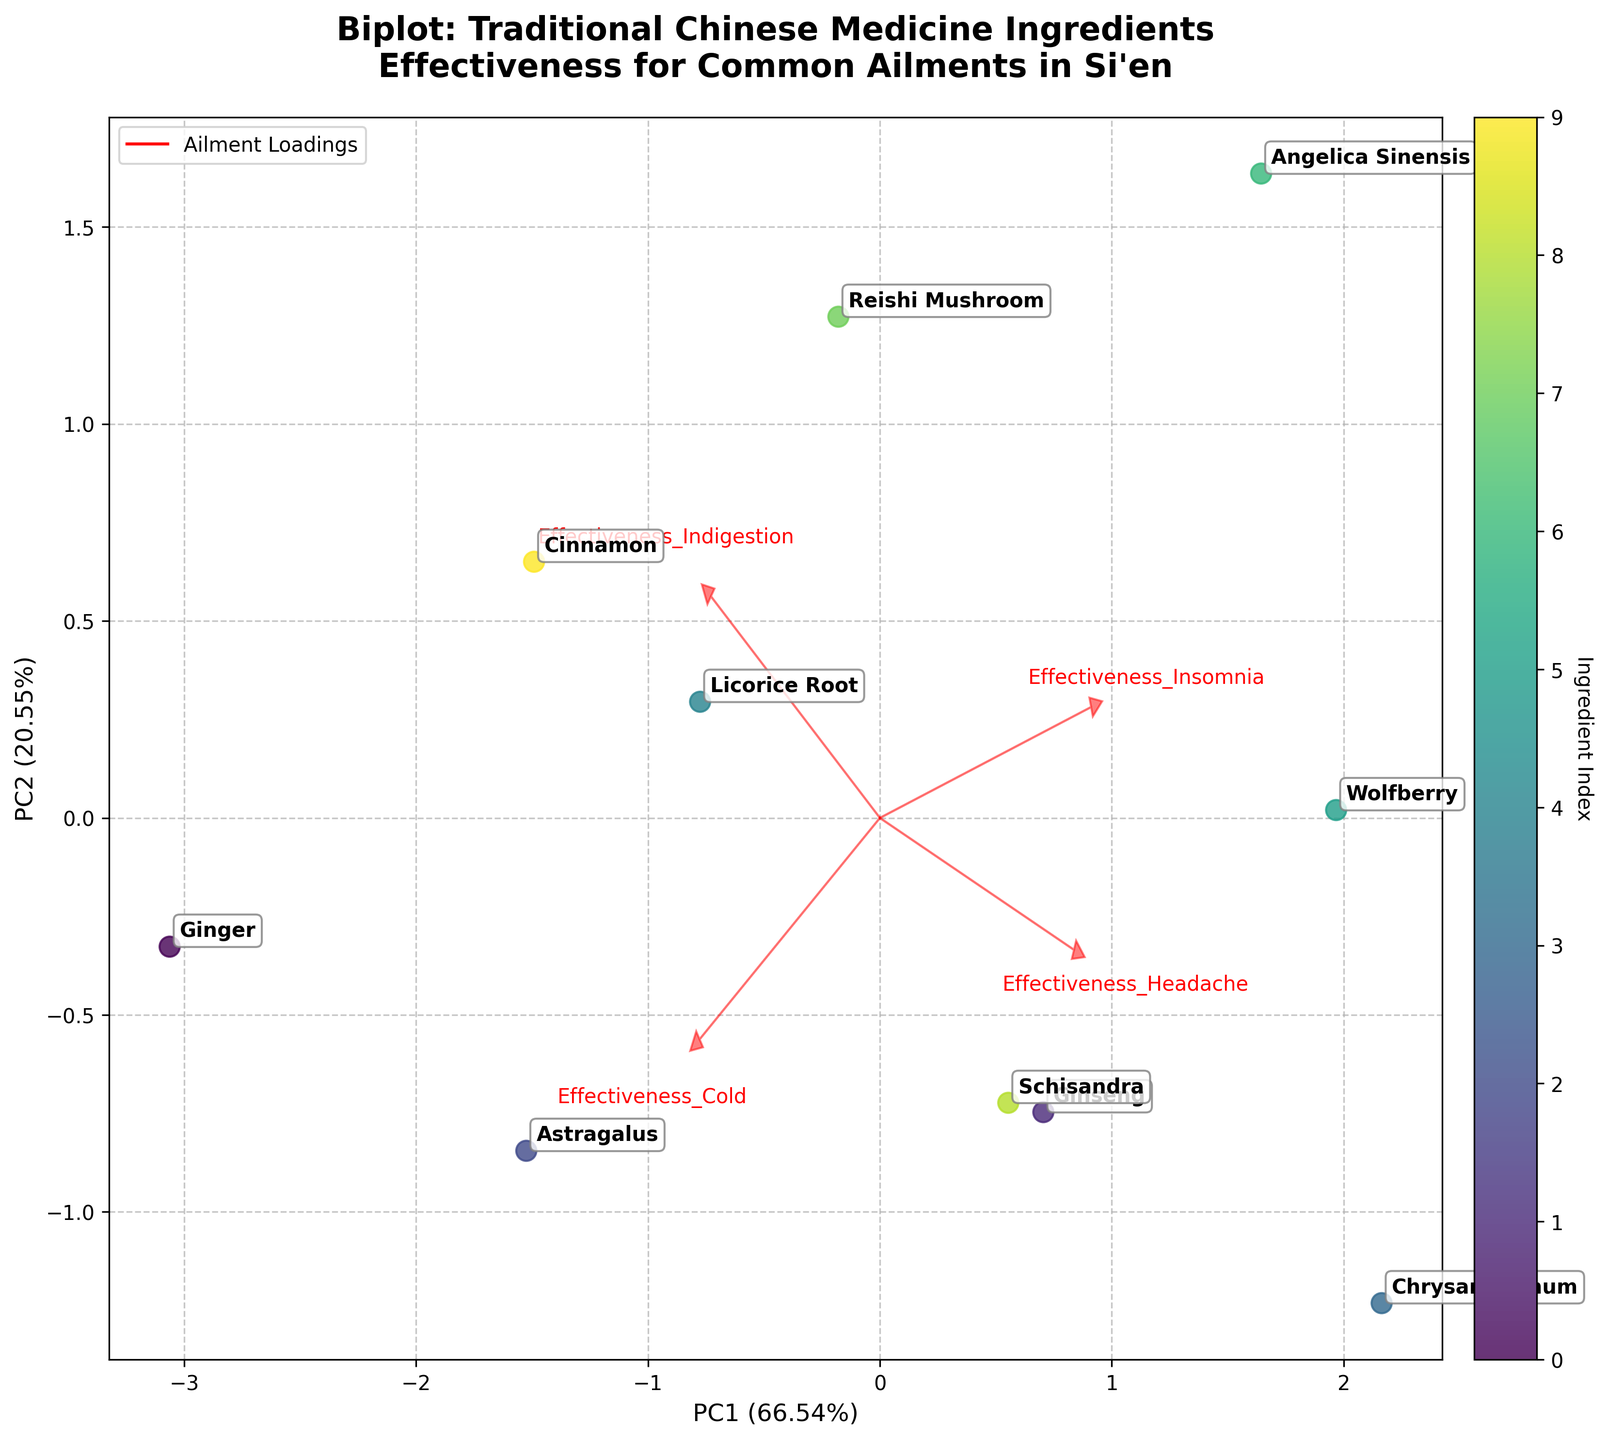What is the effectiveness of Ginger for treating colds? Ginger is located on the plot, and it is influenced by the arrow labeled "Effectiveness_Cold," which points in the positive direction of the first principal component (PC1). The proximity of Ginger to this arrow indicates high effectiveness.
Answer: 0.8 Which ingredient seems to be the most effective for treating insomnia? The arrow labeled "Effectiveness_Insomnia" extends strongly into the plot. The ingredient closest to this arrow is Angelica Sinensis, indicating it has a high effectiveness for treating insomnia.
Answer: Angelica Sinensis What is the horizontal spread among the ingredients in terms of PC1? On the plot, ingredients' scores on PC1 range from negative to positive values. By examining the horizontal axis (PC1), the ingredients spread from left to right, showing their differentiation on the first principal component.
Answer: Wide spread Which ingredient has a balanced effectiveness across all ailments? Schisandra is positioned around the center of the plot, reflecting relatively balanced effectiveness across the ailments, as it's not strongly pulled in any particular arrow's direction.
Answer: Schisandra How much variation is explained by the first two principal components? The x and y-axis labels indicate the variance explained by PC1 and PC2. PC1 accounts for 53.4% and PC2 accounts for 22.1% of the variance respectively. Adding these percentages gives the total explained variance
Answer: 75.5% Is Chrysanthemum more effective for headaches or indigestion? Chrysanthemum is closer to the "Effectiveness_Headache" arrow than to the "Effectiveness_Indigestion" arrow on the plot, indicating higher effectiveness for headaches.
Answer: Headaches What ingredient is closest to PC2 and high in Effectiveness for Headache? Chrysanthemum is close to the Effectiveness_Headache arrow as well as positioned high on PC2 axis, suggesting it's effective for treating headaches.
Answer: Chrysanthemum Which effectiveness vector (arrow) points in the same direction as PC1? The "Effectiveness_Cold" arrow aligns closely with the direction of the positive PC1 axis, indicating it primarily contributes to the first principal component.
Answer: Effectiveness_Cold What is the correlation between Effectiveness for Insomnia and PC2? By observing the direction of the Effectiveness_Insomnia arrow, which aligns closely with the positive y-axis (PC2), it indicates a strong correlation between them.
Answer: Strong correlation 